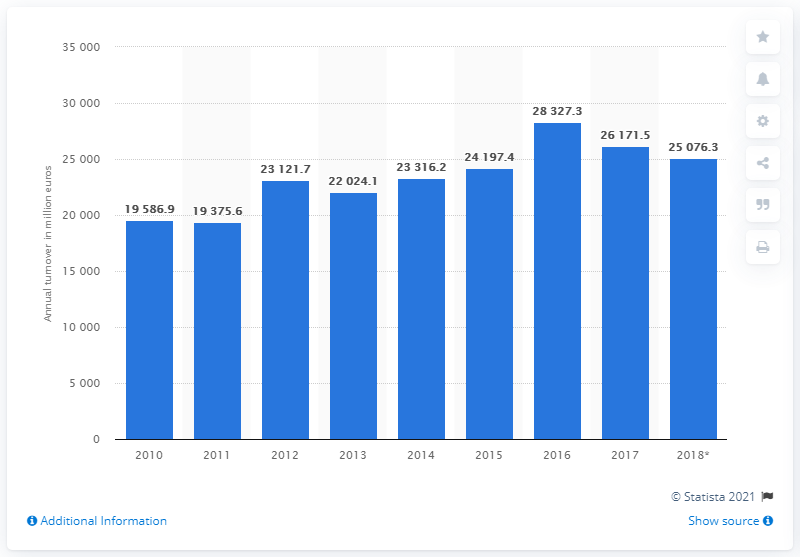Highlight a few significant elements in this photo. The year with the highest value in the first three years is 2012. The number of years with a value above 25000 is 3 or more. In 2017, the turnover of the building construction industry in Belgium was 261,715.5. In 2017, the turnover of the building construction industry in Belgium was 25,076.3. 